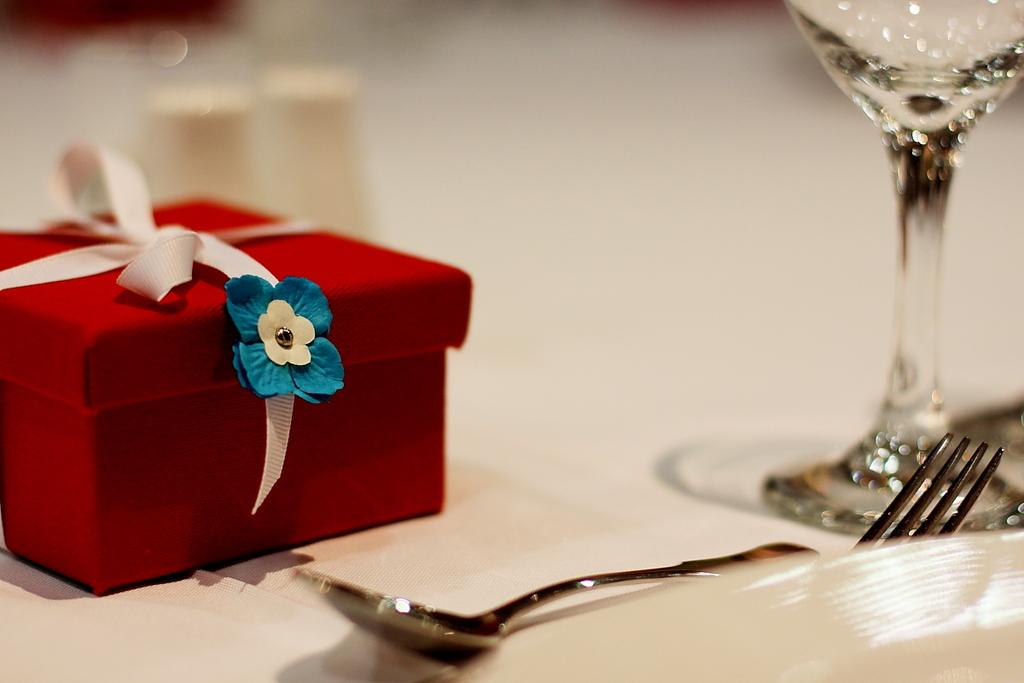What object is placed on the white surface in the image? There is a gift box on the white surface. What is the second object placed on the white surface? There is a ribbon on the white surface. What other objects can be seen on the white surface? There is a glass, a spoon, and a fork on the white surface. What type of ship can be seen sailing in the background of the image? There is no ship present in the image; it only features objects on a white surface. 